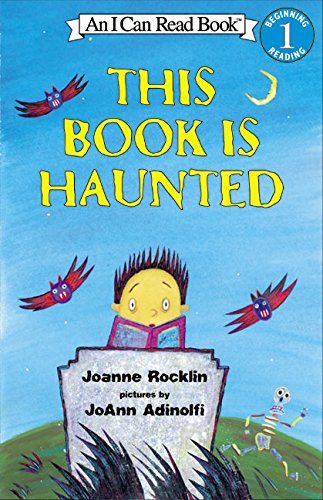Could you describe the illustrations on the cover of this book? The cover features bright and playful illustrations with a child holding a book, from which ghosts and other whimsical figures are emerging, set against a light blue background with flying creatures, suggestive of an engaging and magical story. 